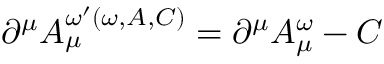Convert formula to latex. <formula><loc_0><loc_0><loc_500><loc_500>\partial ^ { \mu } A _ { \mu } ^ { \omega ^ { \prime } ( \omega , A , C ) } = \partial ^ { \mu } A _ { \mu } ^ { \omega } - C</formula> 